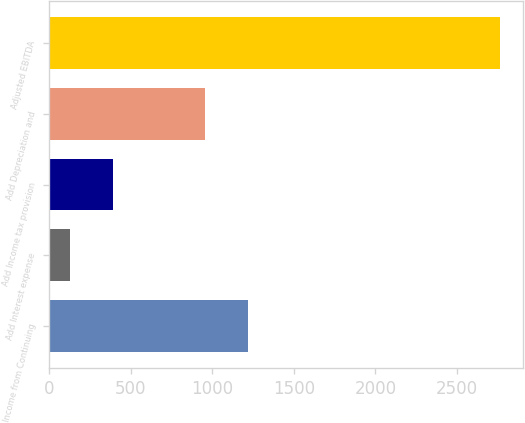Convert chart to OTSL. <chart><loc_0><loc_0><loc_500><loc_500><bar_chart><fcel>Income from Continuing<fcel>Add Interest expense<fcel>Add Income tax provision<fcel>Add Depreciation and<fcel>Adjusted EBITDA<nl><fcel>1220.87<fcel>125.1<fcel>389.07<fcel>956.9<fcel>2764.8<nl></chart> 